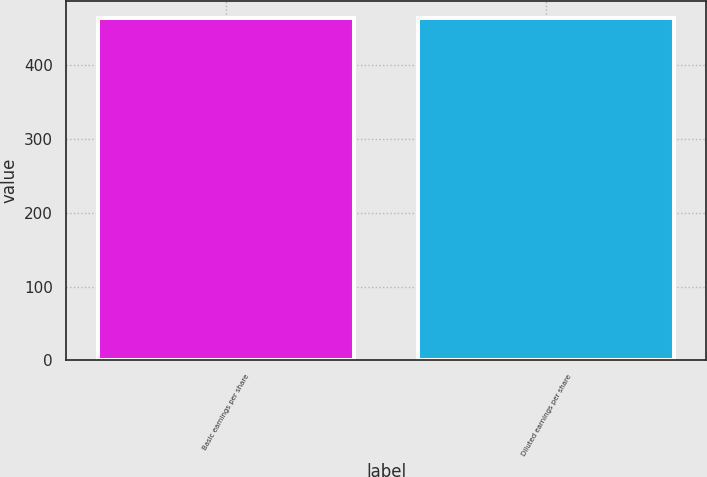<chart> <loc_0><loc_0><loc_500><loc_500><bar_chart><fcel>Basic earnings per share<fcel>Diluted earnings per share<nl><fcel>464.5<fcel>464.6<nl></chart> 